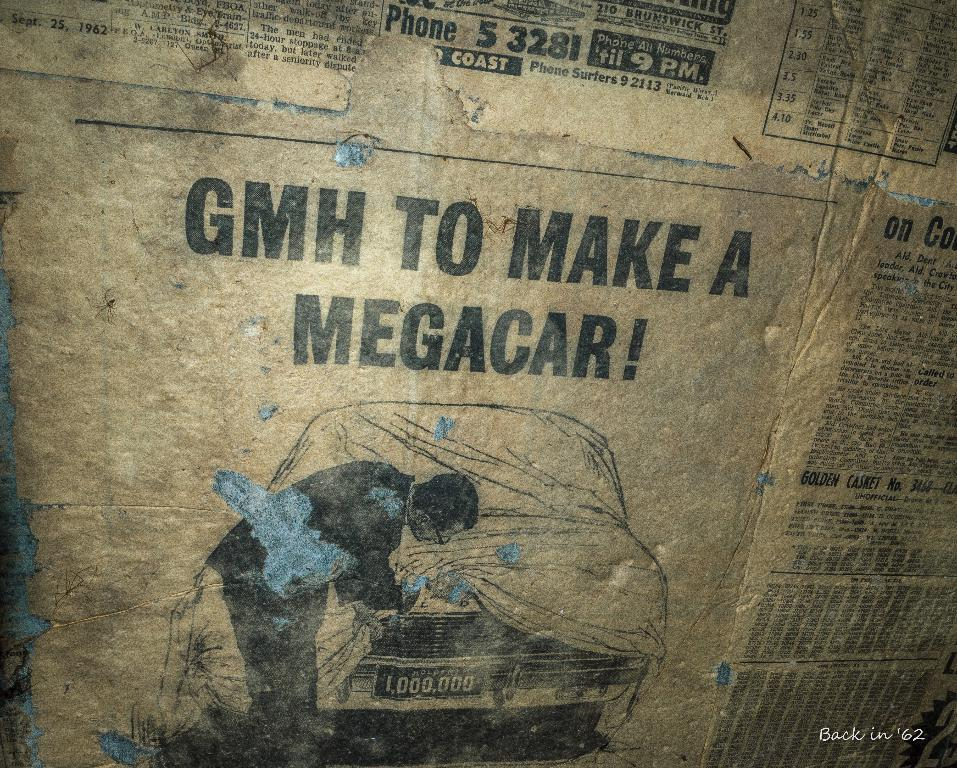What is attached to the wall in the image? There is paper pasted on a wall in the image. Can you describe any specific features of the paper? Unfortunately, the provided facts do not mention any specific features of the paper. Is there any additional information visible in the image? Yes, there is a watermark in the right bottom of the image. Can you tell me how many docks are visible in the image? There are no docks present in the image. What type of note is written on the paper in the image? There is no note written on the paper in the image, as the provided facts do not mention any text or writing. 